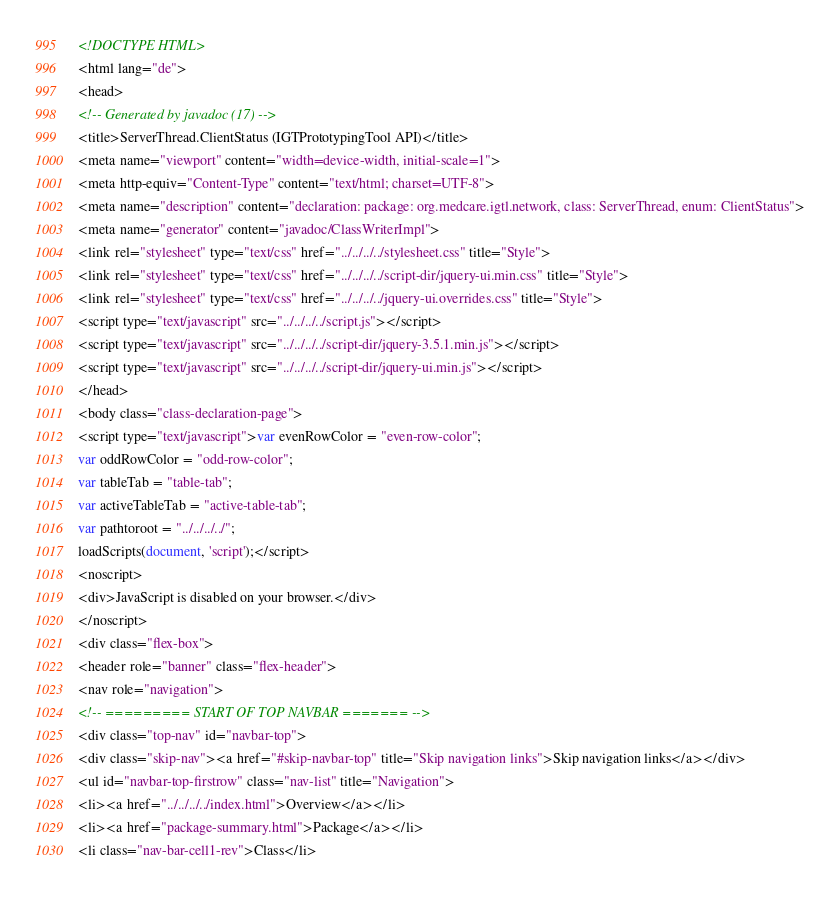<code> <loc_0><loc_0><loc_500><loc_500><_HTML_><!DOCTYPE HTML>
<html lang="de">
<head>
<!-- Generated by javadoc (17) -->
<title>ServerThread.ClientStatus (IGTPrototypingTool API)</title>
<meta name="viewport" content="width=device-width, initial-scale=1">
<meta http-equiv="Content-Type" content="text/html; charset=UTF-8">
<meta name="description" content="declaration: package: org.medcare.igtl.network, class: ServerThread, enum: ClientStatus">
<meta name="generator" content="javadoc/ClassWriterImpl">
<link rel="stylesheet" type="text/css" href="../../../../stylesheet.css" title="Style">
<link rel="stylesheet" type="text/css" href="../../../../script-dir/jquery-ui.min.css" title="Style">
<link rel="stylesheet" type="text/css" href="../../../../jquery-ui.overrides.css" title="Style">
<script type="text/javascript" src="../../../../script.js"></script>
<script type="text/javascript" src="../../../../script-dir/jquery-3.5.1.min.js"></script>
<script type="text/javascript" src="../../../../script-dir/jquery-ui.min.js"></script>
</head>
<body class="class-declaration-page">
<script type="text/javascript">var evenRowColor = "even-row-color";
var oddRowColor = "odd-row-color";
var tableTab = "table-tab";
var activeTableTab = "active-table-tab";
var pathtoroot = "../../../../";
loadScripts(document, 'script');</script>
<noscript>
<div>JavaScript is disabled on your browser.</div>
</noscript>
<div class="flex-box">
<header role="banner" class="flex-header">
<nav role="navigation">
<!-- ========= START OF TOP NAVBAR ======= -->
<div class="top-nav" id="navbar-top">
<div class="skip-nav"><a href="#skip-navbar-top" title="Skip navigation links">Skip navigation links</a></div>
<ul id="navbar-top-firstrow" class="nav-list" title="Navigation">
<li><a href="../../../../index.html">Overview</a></li>
<li><a href="package-summary.html">Package</a></li>
<li class="nav-bar-cell1-rev">Class</li></code> 